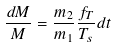<formula> <loc_0><loc_0><loc_500><loc_500>\frac { d M } { M } = \frac { m _ { 2 } } { m _ { 1 } } \frac { f _ { T } } { T _ { s } } d t</formula> 